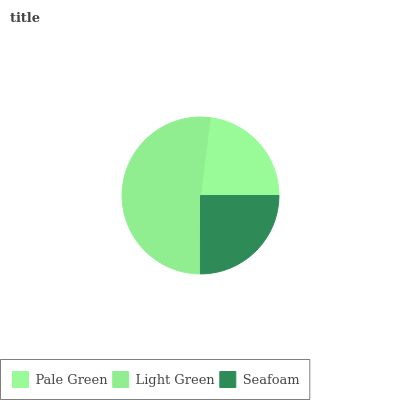Is Pale Green the minimum?
Answer yes or no. Yes. Is Light Green the maximum?
Answer yes or no. Yes. Is Seafoam the minimum?
Answer yes or no. No. Is Seafoam the maximum?
Answer yes or no. No. Is Light Green greater than Seafoam?
Answer yes or no. Yes. Is Seafoam less than Light Green?
Answer yes or no. Yes. Is Seafoam greater than Light Green?
Answer yes or no. No. Is Light Green less than Seafoam?
Answer yes or no. No. Is Seafoam the high median?
Answer yes or no. Yes. Is Seafoam the low median?
Answer yes or no. Yes. Is Pale Green the high median?
Answer yes or no. No. Is Light Green the low median?
Answer yes or no. No. 